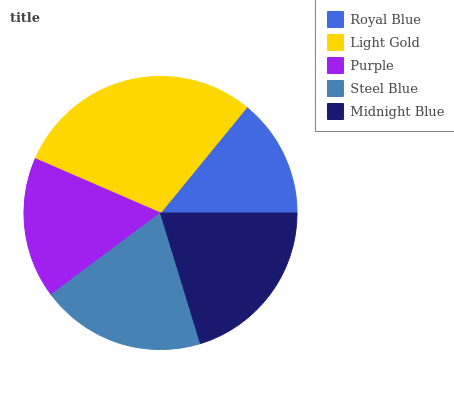Is Royal Blue the minimum?
Answer yes or no. Yes. Is Light Gold the maximum?
Answer yes or no. Yes. Is Purple the minimum?
Answer yes or no. No. Is Purple the maximum?
Answer yes or no. No. Is Light Gold greater than Purple?
Answer yes or no. Yes. Is Purple less than Light Gold?
Answer yes or no. Yes. Is Purple greater than Light Gold?
Answer yes or no. No. Is Light Gold less than Purple?
Answer yes or no. No. Is Steel Blue the high median?
Answer yes or no. Yes. Is Steel Blue the low median?
Answer yes or no. Yes. Is Royal Blue the high median?
Answer yes or no. No. Is Royal Blue the low median?
Answer yes or no. No. 